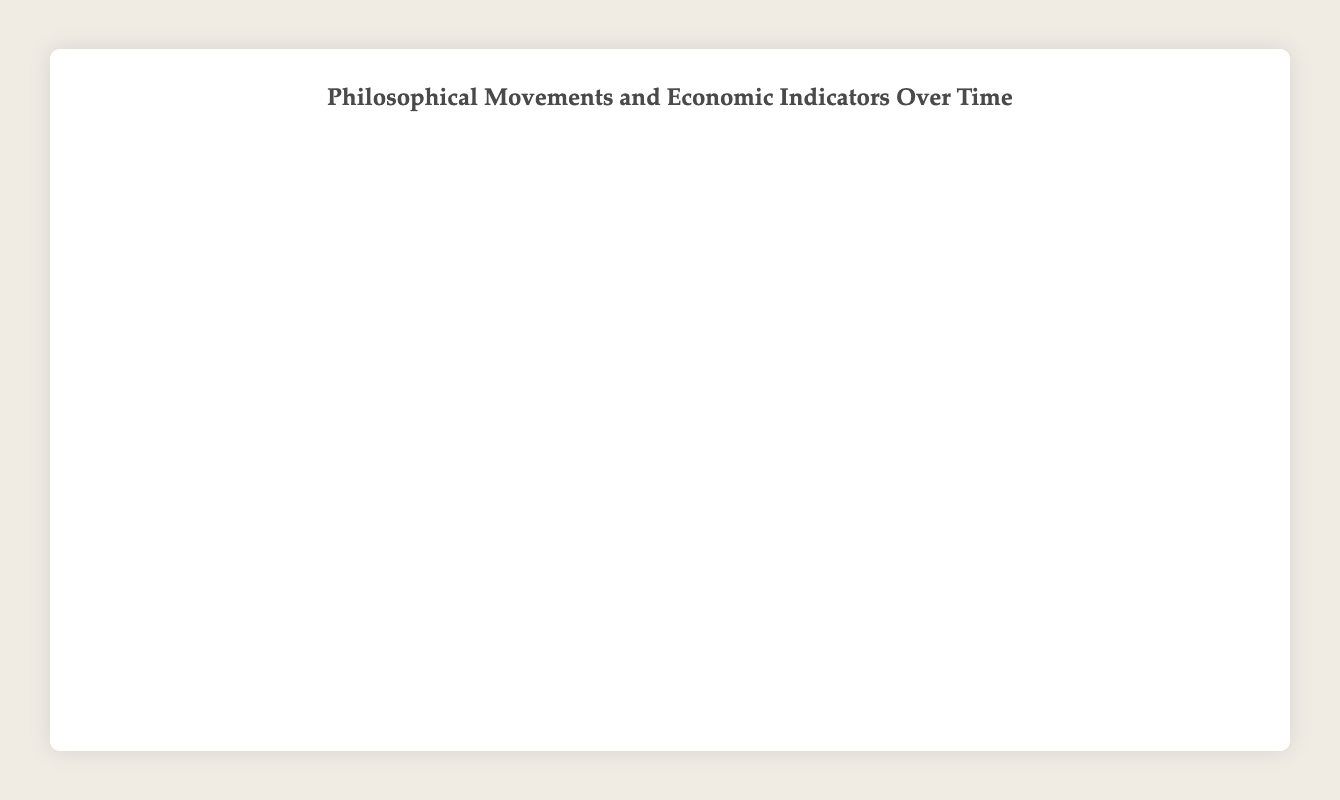What's the title of the bubble chart? The title is displayed at the top-center of the chart, reading "Philosophical Movements and Economic Indicators Over Time".
Answer: Philosophical Movements and Economic Indicators Over Time During which year did the philosophical movement with the highest GDP growth occur? The x-axis represents the year, and the highest point on the y-axis (GDP Growth) is 2000 with the movement "Globalization" having a GDP growth rate of 4.0%.
Answer: 2000 Which philosophical movement had the smallest influence score? The size of the bubble represents the influence score, and the smallest bubble corresponds to "Stoicism" with an influence score of 25.
Answer: Stoicism What’s the difference in the unemployment rate between Stoicism and Postmodernism? Stoicism has an unemployment rate of 2.5% while Postmodernism has 7.0%. The difference is 7.0% - 2.5% = 4.5%.
Answer: 4.5% Which movement has the closest GDP growth rate to the Information Age? Information Age has a GDP growth rate of 3.5%; the closest rate to this is Postmodernism with a GDP growth rate of 3.0%.
Answer: Postmodernism How does inflation rate compare between Rationalism and Globalization? Rationalism has an inflation rate of 1.5% while Globalization has an inflation rate of 1.8%. Globalization's inflation rate is higher.
Answer: Globalization What’s the average influence score of Stoicism and Humanism? The influence score for Stoicism is 25 and for Humanism is 40. Average = (25 + 40) / 2 = 32.5.
Answer: 32.5 During which year did Existentialism peak, and how did its GDP growth compare to Rationalism? Existentialism peaked around 1940 with a GDP growth rate of 2.5%, while Rationalism around 1700 had a GDP growth rate of 2.0%. Existentialism's GDP growth was higher.
Answer: 1940; Higher Can you list the movements in ascending order of their GDP growth rates? Looking at the y-axis values, arranged ascending: Stoicism (0.2), Scholasticism (0.5), Humanism (1.5), Rationalism (2.0), Existentialism (2.5), Postmodernism (3.0), Information Age (3.5), Globalization (4.0).
Answer: Stoicism, Scholasticism, Humanism, Rationalism, Existentialism, Postmodernism, Information Age, Globalization 